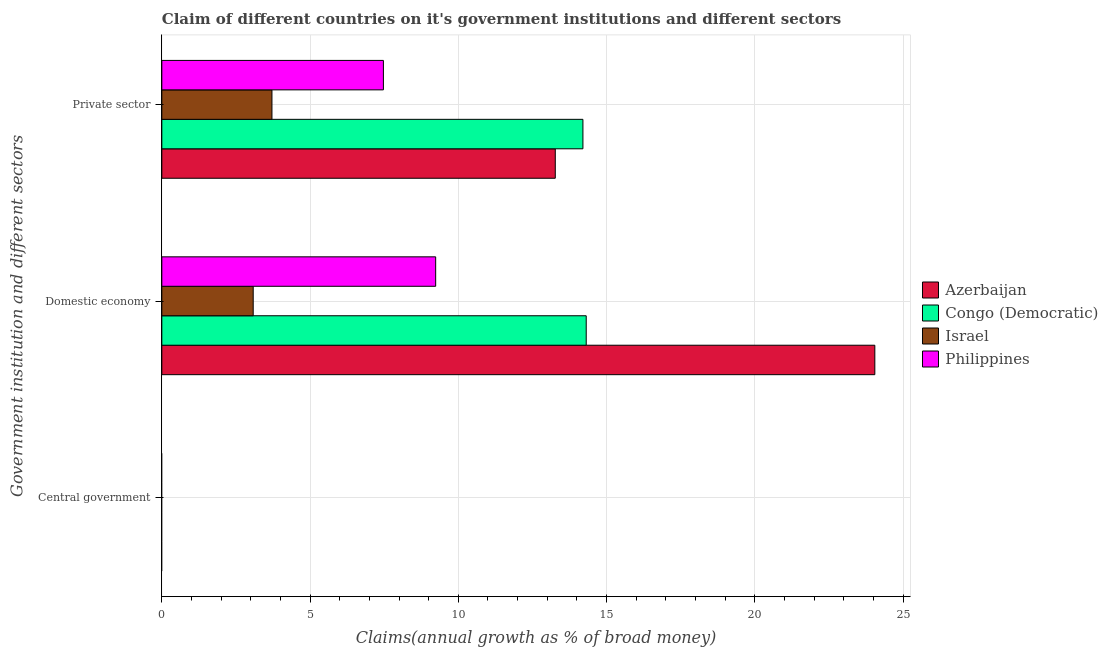Are the number of bars per tick equal to the number of legend labels?
Provide a succinct answer. No. Are the number of bars on each tick of the Y-axis equal?
Offer a terse response. No. How many bars are there on the 3rd tick from the top?
Offer a terse response. 0. What is the label of the 2nd group of bars from the top?
Your response must be concise. Domestic economy. What is the percentage of claim on the domestic economy in Congo (Democratic)?
Your response must be concise. 14.31. Across all countries, what is the maximum percentage of claim on the domestic economy?
Your answer should be very brief. 24.05. Across all countries, what is the minimum percentage of claim on the domestic economy?
Provide a short and direct response. 3.08. In which country was the percentage of claim on the domestic economy maximum?
Give a very brief answer. Azerbaijan. What is the difference between the percentage of claim on the domestic economy in Azerbaijan and that in Philippines?
Your answer should be very brief. 14.81. What is the difference between the percentage of claim on the private sector in Philippines and the percentage of claim on the central government in Azerbaijan?
Your answer should be very brief. 7.47. What is the average percentage of claim on the central government per country?
Give a very brief answer. 0. What is the difference between the percentage of claim on the private sector and percentage of claim on the domestic economy in Israel?
Give a very brief answer. 0.63. What is the ratio of the percentage of claim on the private sector in Israel to that in Philippines?
Your answer should be compact. 0.5. Is the percentage of claim on the private sector in Congo (Democratic) less than that in Azerbaijan?
Offer a terse response. No. Is the difference between the percentage of claim on the domestic economy in Azerbaijan and Israel greater than the difference between the percentage of claim on the private sector in Azerbaijan and Israel?
Make the answer very short. Yes. What is the difference between the highest and the second highest percentage of claim on the private sector?
Your answer should be compact. 0.93. What is the difference between the highest and the lowest percentage of claim on the private sector?
Keep it short and to the point. 10.49. In how many countries, is the percentage of claim on the central government greater than the average percentage of claim on the central government taken over all countries?
Keep it short and to the point. 0. How many countries are there in the graph?
Provide a short and direct response. 4. Does the graph contain any zero values?
Offer a very short reply. Yes. Where does the legend appear in the graph?
Provide a short and direct response. Center right. How many legend labels are there?
Provide a succinct answer. 4. What is the title of the graph?
Give a very brief answer. Claim of different countries on it's government institutions and different sectors. What is the label or title of the X-axis?
Offer a very short reply. Claims(annual growth as % of broad money). What is the label or title of the Y-axis?
Provide a succinct answer. Government institution and different sectors. What is the Claims(annual growth as % of broad money) of Azerbaijan in Central government?
Provide a succinct answer. 0. What is the Claims(annual growth as % of broad money) of Azerbaijan in Domestic economy?
Your answer should be very brief. 24.05. What is the Claims(annual growth as % of broad money) of Congo (Democratic) in Domestic economy?
Provide a succinct answer. 14.31. What is the Claims(annual growth as % of broad money) in Israel in Domestic economy?
Offer a terse response. 3.08. What is the Claims(annual growth as % of broad money) of Philippines in Domestic economy?
Provide a succinct answer. 9.24. What is the Claims(annual growth as % of broad money) of Azerbaijan in Private sector?
Ensure brevity in your answer.  13.27. What is the Claims(annual growth as % of broad money) in Congo (Democratic) in Private sector?
Provide a short and direct response. 14.2. What is the Claims(annual growth as % of broad money) in Israel in Private sector?
Your answer should be very brief. 3.71. What is the Claims(annual growth as % of broad money) of Philippines in Private sector?
Give a very brief answer. 7.47. Across all Government institution and different sectors, what is the maximum Claims(annual growth as % of broad money) of Azerbaijan?
Your answer should be compact. 24.05. Across all Government institution and different sectors, what is the maximum Claims(annual growth as % of broad money) of Congo (Democratic)?
Provide a short and direct response. 14.31. Across all Government institution and different sectors, what is the maximum Claims(annual growth as % of broad money) of Israel?
Ensure brevity in your answer.  3.71. Across all Government institution and different sectors, what is the maximum Claims(annual growth as % of broad money) of Philippines?
Your answer should be very brief. 9.24. Across all Government institution and different sectors, what is the minimum Claims(annual growth as % of broad money) of Azerbaijan?
Give a very brief answer. 0. Across all Government institution and different sectors, what is the minimum Claims(annual growth as % of broad money) in Philippines?
Offer a terse response. 0. What is the total Claims(annual growth as % of broad money) of Azerbaijan in the graph?
Offer a very short reply. 37.32. What is the total Claims(annual growth as % of broad money) in Congo (Democratic) in the graph?
Provide a short and direct response. 28.52. What is the total Claims(annual growth as % of broad money) in Israel in the graph?
Provide a succinct answer. 6.8. What is the total Claims(annual growth as % of broad money) of Philippines in the graph?
Your answer should be compact. 16.71. What is the difference between the Claims(annual growth as % of broad money) of Azerbaijan in Domestic economy and that in Private sector?
Give a very brief answer. 10.78. What is the difference between the Claims(annual growth as % of broad money) in Congo (Democratic) in Domestic economy and that in Private sector?
Keep it short and to the point. 0.11. What is the difference between the Claims(annual growth as % of broad money) in Israel in Domestic economy and that in Private sector?
Your answer should be compact. -0.63. What is the difference between the Claims(annual growth as % of broad money) of Philippines in Domestic economy and that in Private sector?
Offer a terse response. 1.76. What is the difference between the Claims(annual growth as % of broad money) of Azerbaijan in Domestic economy and the Claims(annual growth as % of broad money) of Congo (Democratic) in Private sector?
Provide a succinct answer. 9.85. What is the difference between the Claims(annual growth as % of broad money) of Azerbaijan in Domestic economy and the Claims(annual growth as % of broad money) of Israel in Private sector?
Make the answer very short. 20.33. What is the difference between the Claims(annual growth as % of broad money) in Azerbaijan in Domestic economy and the Claims(annual growth as % of broad money) in Philippines in Private sector?
Your response must be concise. 16.57. What is the difference between the Claims(annual growth as % of broad money) in Congo (Democratic) in Domestic economy and the Claims(annual growth as % of broad money) in Israel in Private sector?
Give a very brief answer. 10.6. What is the difference between the Claims(annual growth as % of broad money) in Congo (Democratic) in Domestic economy and the Claims(annual growth as % of broad money) in Philippines in Private sector?
Give a very brief answer. 6.84. What is the difference between the Claims(annual growth as % of broad money) of Israel in Domestic economy and the Claims(annual growth as % of broad money) of Philippines in Private sector?
Make the answer very short. -4.39. What is the average Claims(annual growth as % of broad money) in Azerbaijan per Government institution and different sectors?
Your answer should be compact. 12.44. What is the average Claims(annual growth as % of broad money) of Congo (Democratic) per Government institution and different sectors?
Offer a terse response. 9.51. What is the average Claims(annual growth as % of broad money) of Israel per Government institution and different sectors?
Offer a terse response. 2.27. What is the average Claims(annual growth as % of broad money) of Philippines per Government institution and different sectors?
Provide a succinct answer. 5.57. What is the difference between the Claims(annual growth as % of broad money) in Azerbaijan and Claims(annual growth as % of broad money) in Congo (Democratic) in Domestic economy?
Keep it short and to the point. 9.73. What is the difference between the Claims(annual growth as % of broad money) of Azerbaijan and Claims(annual growth as % of broad money) of Israel in Domestic economy?
Your answer should be very brief. 20.97. What is the difference between the Claims(annual growth as % of broad money) in Azerbaijan and Claims(annual growth as % of broad money) in Philippines in Domestic economy?
Ensure brevity in your answer.  14.81. What is the difference between the Claims(annual growth as % of broad money) of Congo (Democratic) and Claims(annual growth as % of broad money) of Israel in Domestic economy?
Your answer should be very brief. 11.23. What is the difference between the Claims(annual growth as % of broad money) in Congo (Democratic) and Claims(annual growth as % of broad money) in Philippines in Domestic economy?
Make the answer very short. 5.08. What is the difference between the Claims(annual growth as % of broad money) of Israel and Claims(annual growth as % of broad money) of Philippines in Domestic economy?
Ensure brevity in your answer.  -6.15. What is the difference between the Claims(annual growth as % of broad money) of Azerbaijan and Claims(annual growth as % of broad money) of Congo (Democratic) in Private sector?
Provide a succinct answer. -0.93. What is the difference between the Claims(annual growth as % of broad money) of Azerbaijan and Claims(annual growth as % of broad money) of Israel in Private sector?
Give a very brief answer. 9.56. What is the difference between the Claims(annual growth as % of broad money) of Azerbaijan and Claims(annual growth as % of broad money) of Philippines in Private sector?
Give a very brief answer. 5.8. What is the difference between the Claims(annual growth as % of broad money) of Congo (Democratic) and Claims(annual growth as % of broad money) of Israel in Private sector?
Make the answer very short. 10.49. What is the difference between the Claims(annual growth as % of broad money) of Congo (Democratic) and Claims(annual growth as % of broad money) of Philippines in Private sector?
Offer a terse response. 6.73. What is the difference between the Claims(annual growth as % of broad money) in Israel and Claims(annual growth as % of broad money) in Philippines in Private sector?
Ensure brevity in your answer.  -3.76. What is the ratio of the Claims(annual growth as % of broad money) of Azerbaijan in Domestic economy to that in Private sector?
Ensure brevity in your answer.  1.81. What is the ratio of the Claims(annual growth as % of broad money) of Israel in Domestic economy to that in Private sector?
Give a very brief answer. 0.83. What is the ratio of the Claims(annual growth as % of broad money) in Philippines in Domestic economy to that in Private sector?
Your response must be concise. 1.24. What is the difference between the highest and the lowest Claims(annual growth as % of broad money) of Azerbaijan?
Offer a terse response. 24.05. What is the difference between the highest and the lowest Claims(annual growth as % of broad money) of Congo (Democratic)?
Your answer should be very brief. 14.31. What is the difference between the highest and the lowest Claims(annual growth as % of broad money) of Israel?
Provide a succinct answer. 3.71. What is the difference between the highest and the lowest Claims(annual growth as % of broad money) of Philippines?
Your answer should be very brief. 9.24. 